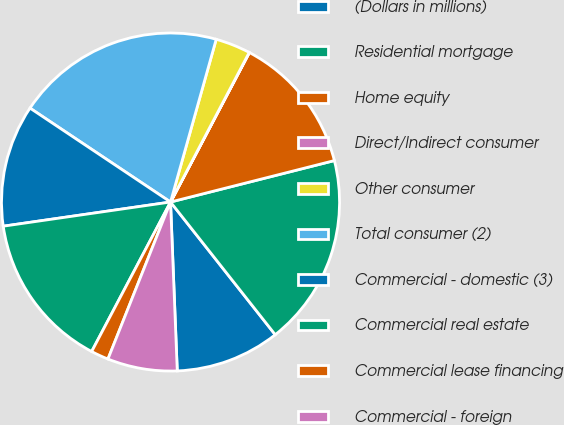Convert chart. <chart><loc_0><loc_0><loc_500><loc_500><pie_chart><fcel>(Dollars in millions)<fcel>Residential mortgage<fcel>Home equity<fcel>Direct/Indirect consumer<fcel>Other consumer<fcel>Total consumer (2)<fcel>Commercial - domestic (3)<fcel>Commercial real estate<fcel>Commercial lease financing<fcel>Commercial - foreign<nl><fcel>10.0%<fcel>18.31%<fcel>13.33%<fcel>0.02%<fcel>3.35%<fcel>19.98%<fcel>11.66%<fcel>14.99%<fcel>1.69%<fcel>6.67%<nl></chart> 